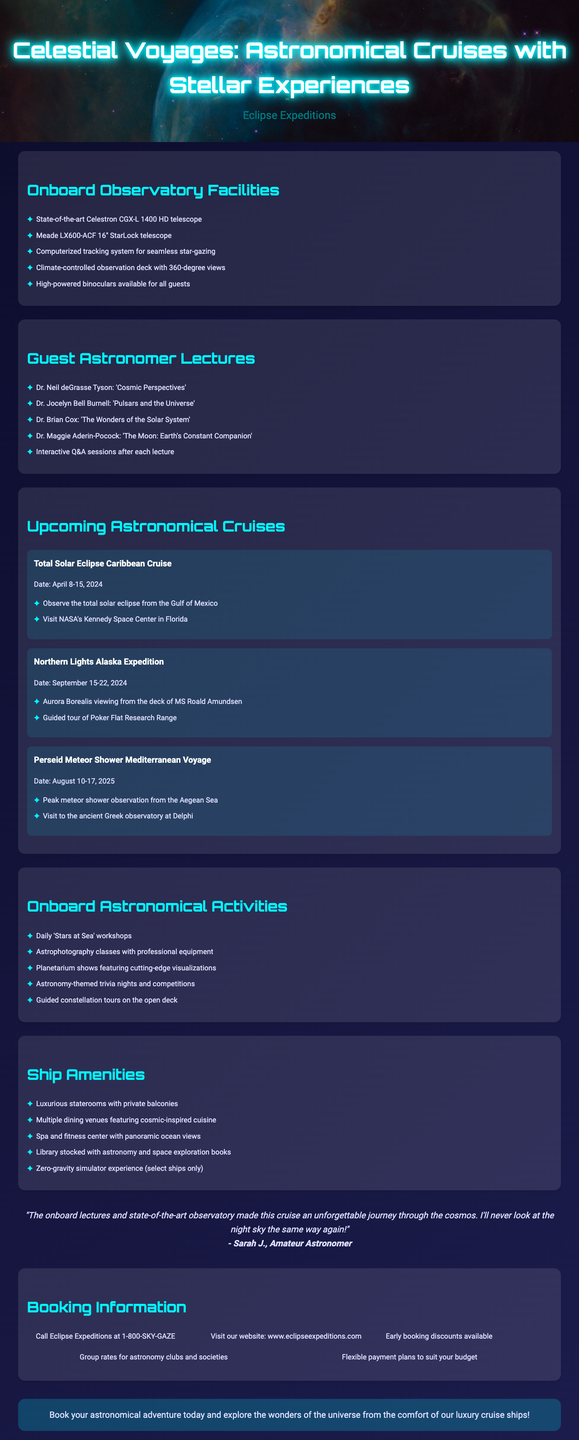What is the title of the brochure? The title of the brochure is found at the top and is a key element of the document.
Answer: Celestial Voyages: Astronomical Cruises with Stellar Experiences Who is the company behind the cruises? The company's name is presented prominently on the brochure, indicating who offers the service.
Answer: Eclipse Expeditions What is the date of the Total Solar Eclipse Caribbean Cruise? The date is clearly stated under the upcoming cruises section, providing specific timing for an event.
Answer: April 8-15, 2024 Which telescope is noted for state-of-the-art facilities? The brochure specifies the featured equipment available for guests, highlighting quality options.
Answer: Celestron CGX-L 1400 HD telescope Who is the guest astronomer presenting "Cosmic Perspectives"? Identifying speakers in the lectures adds credibility and interest to the events.
Answer: Dr. Neil deGrasse Tyson What type of staterooms are offered on the cruise? The amenities section of the brochure outlines available accommodations, highlighting the luxury aspect.
Answer: Luxurious staterooms with private balconies How many upcoming astronomical cruises are mentioned? Counting events in the upcoming section provides a quick reference for the scope of offerings.
Answer: Three What activity involves guided constellation tours? The specific activities on board highlight the interactive experiences guests can expect.
Answer: Onboard Astronomical Activities What is one of the highlights of the Northern Lights Alaska Expedition? Extracting key features of the cruises helps illustrate the unique experiences offered to participants.
Answer: Aurora Borealis viewing from the deck of MS Roald Amundsen 